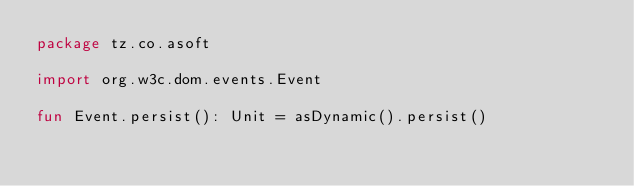Convert code to text. <code><loc_0><loc_0><loc_500><loc_500><_Kotlin_>package tz.co.asoft

import org.w3c.dom.events.Event

fun Event.persist(): Unit = asDynamic().persist()</code> 